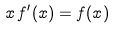<formula> <loc_0><loc_0><loc_500><loc_500>x \, f ^ { \prime } ( x ) = f ( x )</formula> 